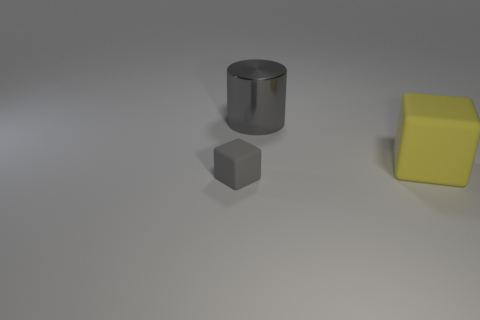Add 3 small brown metallic balls. How many objects exist? 6 Subtract all cylinders. How many objects are left? 2 Add 2 big yellow matte cubes. How many big yellow matte cubes are left? 3 Add 2 tiny purple matte cylinders. How many tiny purple matte cylinders exist? 2 Subtract 0 cyan spheres. How many objects are left? 3 Subtract all small green shiny things. Subtract all large yellow cubes. How many objects are left? 2 